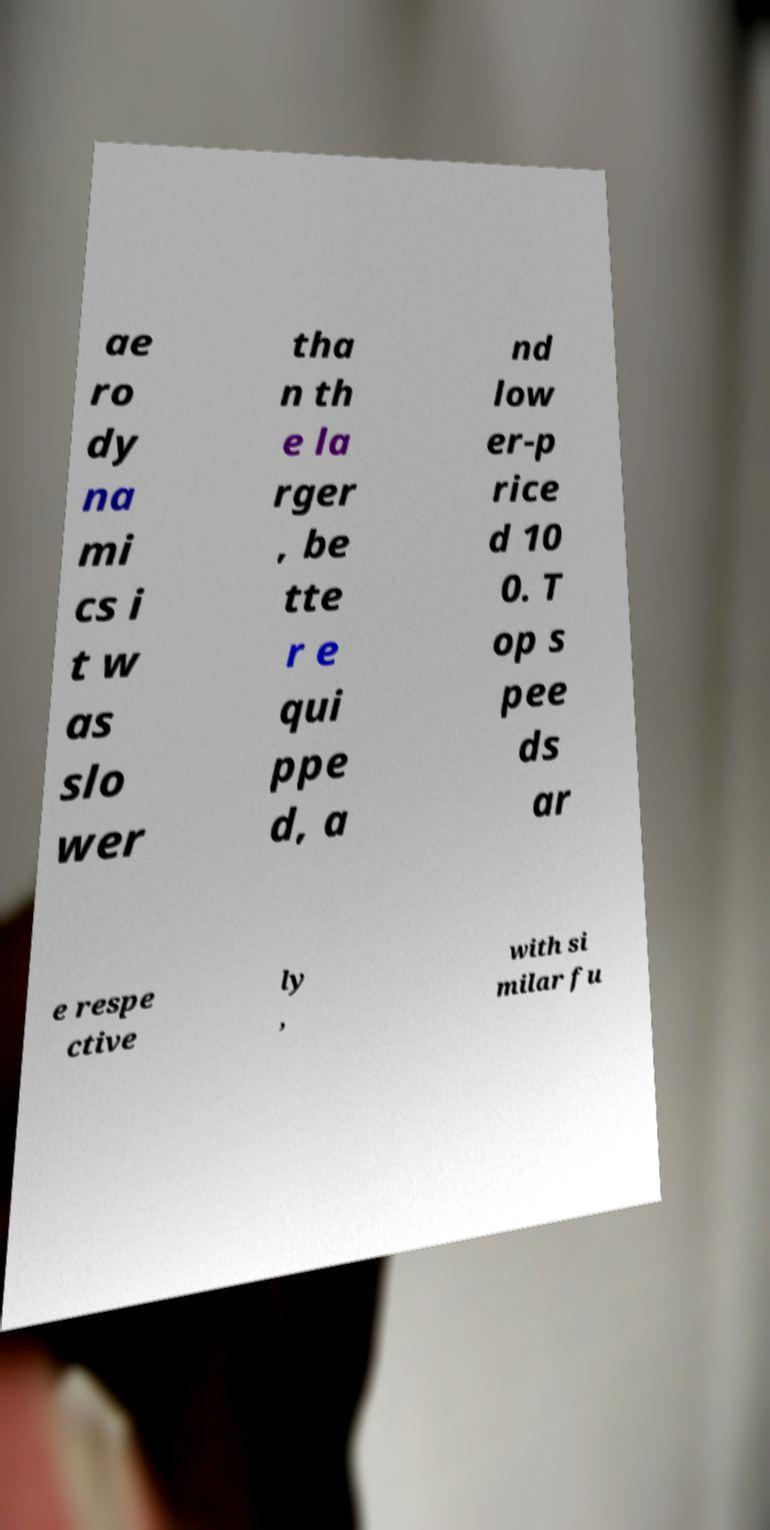Can you accurately transcribe the text from the provided image for me? ae ro dy na mi cs i t w as slo wer tha n th e la rger , be tte r e qui ppe d, a nd low er-p rice d 10 0. T op s pee ds ar e respe ctive ly , with si milar fu 